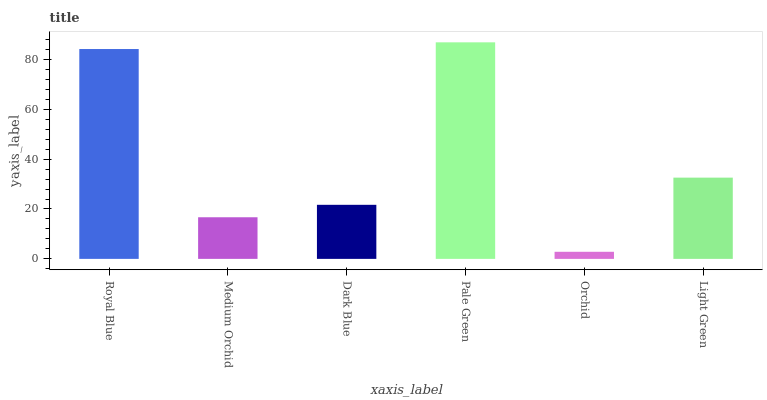Is Orchid the minimum?
Answer yes or no. Yes. Is Pale Green the maximum?
Answer yes or no. Yes. Is Medium Orchid the minimum?
Answer yes or no. No. Is Medium Orchid the maximum?
Answer yes or no. No. Is Royal Blue greater than Medium Orchid?
Answer yes or no. Yes. Is Medium Orchid less than Royal Blue?
Answer yes or no. Yes. Is Medium Orchid greater than Royal Blue?
Answer yes or no. No. Is Royal Blue less than Medium Orchid?
Answer yes or no. No. Is Light Green the high median?
Answer yes or no. Yes. Is Dark Blue the low median?
Answer yes or no. Yes. Is Medium Orchid the high median?
Answer yes or no. No. Is Orchid the low median?
Answer yes or no. No. 